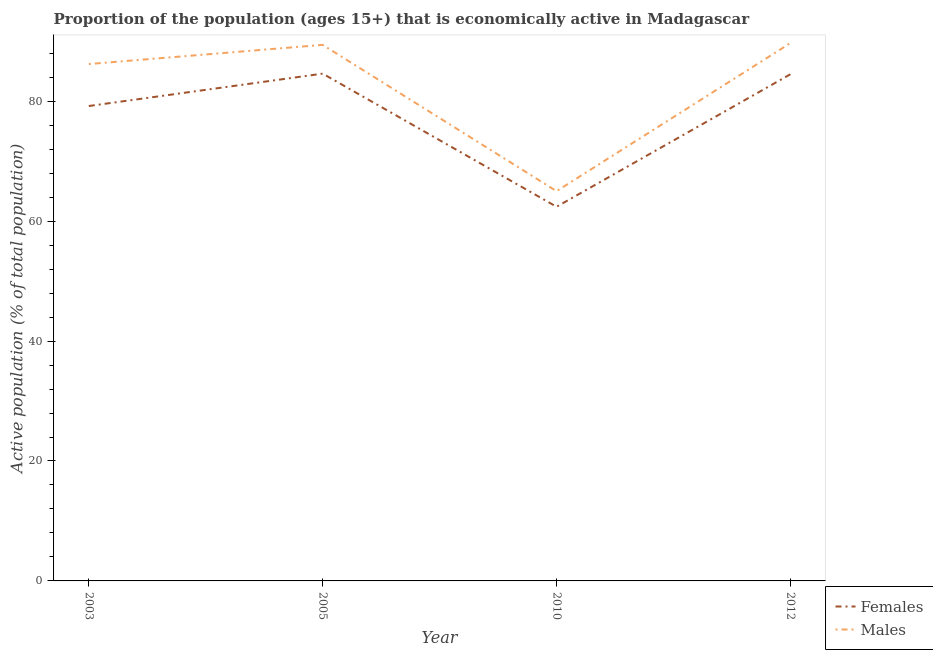Is the number of lines equal to the number of legend labels?
Ensure brevity in your answer.  Yes. What is the percentage of economically active male population in 2005?
Provide a succinct answer. 89.4. Across all years, what is the maximum percentage of economically active male population?
Provide a succinct answer. 89.7. In which year was the percentage of economically active female population maximum?
Your response must be concise. 2005. In which year was the percentage of economically active male population minimum?
Your answer should be very brief. 2010. What is the total percentage of economically active male population in the graph?
Give a very brief answer. 330.3. What is the difference between the percentage of economically active female population in 2003 and that in 2005?
Your answer should be compact. -5.4. What is the difference between the percentage of economically active male population in 2012 and the percentage of economically active female population in 2010?
Provide a short and direct response. 27.3. What is the average percentage of economically active female population per year?
Ensure brevity in your answer.  77.67. In the year 2012, what is the difference between the percentage of economically active female population and percentage of economically active male population?
Make the answer very short. -5.2. In how many years, is the percentage of economically active male population greater than 8 %?
Give a very brief answer. 4. What is the ratio of the percentage of economically active female population in 2003 to that in 2012?
Offer a very short reply. 0.94. Is the percentage of economically active female population in 2003 less than that in 2010?
Your answer should be very brief. No. Is the difference between the percentage of economically active female population in 2003 and 2012 greater than the difference between the percentage of economically active male population in 2003 and 2012?
Offer a very short reply. No. What is the difference between the highest and the second highest percentage of economically active female population?
Your response must be concise. 0.1. What is the difference between the highest and the lowest percentage of economically active male population?
Make the answer very short. 24.7. In how many years, is the percentage of economically active male population greater than the average percentage of economically active male population taken over all years?
Offer a terse response. 3. Is the percentage of economically active male population strictly greater than the percentage of economically active female population over the years?
Your response must be concise. Yes. Is the percentage of economically active female population strictly less than the percentage of economically active male population over the years?
Your response must be concise. Yes. Are the values on the major ticks of Y-axis written in scientific E-notation?
Offer a very short reply. No. Does the graph contain any zero values?
Your response must be concise. No. Does the graph contain grids?
Offer a very short reply. No. Where does the legend appear in the graph?
Your response must be concise. Bottom right. How are the legend labels stacked?
Ensure brevity in your answer.  Vertical. What is the title of the graph?
Keep it short and to the point. Proportion of the population (ages 15+) that is economically active in Madagascar. What is the label or title of the Y-axis?
Provide a succinct answer. Active population (% of total population). What is the Active population (% of total population) of Females in 2003?
Provide a succinct answer. 79.2. What is the Active population (% of total population) of Males in 2003?
Offer a very short reply. 86.2. What is the Active population (% of total population) of Females in 2005?
Offer a terse response. 84.6. What is the Active population (% of total population) of Males in 2005?
Provide a short and direct response. 89.4. What is the Active population (% of total population) of Females in 2010?
Keep it short and to the point. 62.4. What is the Active population (% of total population) in Males in 2010?
Your answer should be compact. 65. What is the Active population (% of total population) of Females in 2012?
Your answer should be very brief. 84.5. What is the Active population (% of total population) in Males in 2012?
Keep it short and to the point. 89.7. Across all years, what is the maximum Active population (% of total population) of Females?
Your answer should be compact. 84.6. Across all years, what is the maximum Active population (% of total population) of Males?
Provide a succinct answer. 89.7. Across all years, what is the minimum Active population (% of total population) of Females?
Provide a short and direct response. 62.4. Across all years, what is the minimum Active population (% of total population) in Males?
Make the answer very short. 65. What is the total Active population (% of total population) in Females in the graph?
Provide a short and direct response. 310.7. What is the total Active population (% of total population) in Males in the graph?
Your answer should be very brief. 330.3. What is the difference between the Active population (% of total population) in Females in 2003 and that in 2005?
Your answer should be compact. -5.4. What is the difference between the Active population (% of total population) of Males in 2003 and that in 2005?
Offer a very short reply. -3.2. What is the difference between the Active population (% of total population) of Females in 2003 and that in 2010?
Provide a short and direct response. 16.8. What is the difference between the Active population (% of total population) of Males in 2003 and that in 2010?
Your answer should be very brief. 21.2. What is the difference between the Active population (% of total population) in Females in 2003 and that in 2012?
Offer a terse response. -5.3. What is the difference between the Active population (% of total population) of Males in 2003 and that in 2012?
Your answer should be very brief. -3.5. What is the difference between the Active population (% of total population) of Females in 2005 and that in 2010?
Give a very brief answer. 22.2. What is the difference between the Active population (% of total population) of Males in 2005 and that in 2010?
Your response must be concise. 24.4. What is the difference between the Active population (% of total population) of Males in 2005 and that in 2012?
Offer a very short reply. -0.3. What is the difference between the Active population (% of total population) of Females in 2010 and that in 2012?
Give a very brief answer. -22.1. What is the difference between the Active population (% of total population) of Males in 2010 and that in 2012?
Offer a terse response. -24.7. What is the difference between the Active population (% of total population) of Females in 2003 and the Active population (% of total population) of Males in 2010?
Offer a very short reply. 14.2. What is the difference between the Active population (% of total population) of Females in 2005 and the Active population (% of total population) of Males in 2010?
Make the answer very short. 19.6. What is the difference between the Active population (% of total population) in Females in 2010 and the Active population (% of total population) in Males in 2012?
Keep it short and to the point. -27.3. What is the average Active population (% of total population) of Females per year?
Your response must be concise. 77.67. What is the average Active population (% of total population) of Males per year?
Keep it short and to the point. 82.58. In the year 2005, what is the difference between the Active population (% of total population) of Females and Active population (% of total population) of Males?
Offer a terse response. -4.8. In the year 2012, what is the difference between the Active population (% of total population) of Females and Active population (% of total population) of Males?
Make the answer very short. -5.2. What is the ratio of the Active population (% of total population) of Females in 2003 to that in 2005?
Offer a terse response. 0.94. What is the ratio of the Active population (% of total population) of Males in 2003 to that in 2005?
Keep it short and to the point. 0.96. What is the ratio of the Active population (% of total population) of Females in 2003 to that in 2010?
Give a very brief answer. 1.27. What is the ratio of the Active population (% of total population) of Males in 2003 to that in 2010?
Ensure brevity in your answer.  1.33. What is the ratio of the Active population (% of total population) in Females in 2003 to that in 2012?
Your response must be concise. 0.94. What is the ratio of the Active population (% of total population) of Males in 2003 to that in 2012?
Make the answer very short. 0.96. What is the ratio of the Active population (% of total population) in Females in 2005 to that in 2010?
Make the answer very short. 1.36. What is the ratio of the Active population (% of total population) of Males in 2005 to that in 2010?
Your answer should be compact. 1.38. What is the ratio of the Active population (% of total population) in Males in 2005 to that in 2012?
Offer a terse response. 1. What is the ratio of the Active population (% of total population) of Females in 2010 to that in 2012?
Give a very brief answer. 0.74. What is the ratio of the Active population (% of total population) in Males in 2010 to that in 2012?
Offer a very short reply. 0.72. What is the difference between the highest and the second highest Active population (% of total population) in Females?
Offer a terse response. 0.1. What is the difference between the highest and the second highest Active population (% of total population) of Males?
Provide a succinct answer. 0.3. What is the difference between the highest and the lowest Active population (% of total population) of Males?
Your response must be concise. 24.7. 